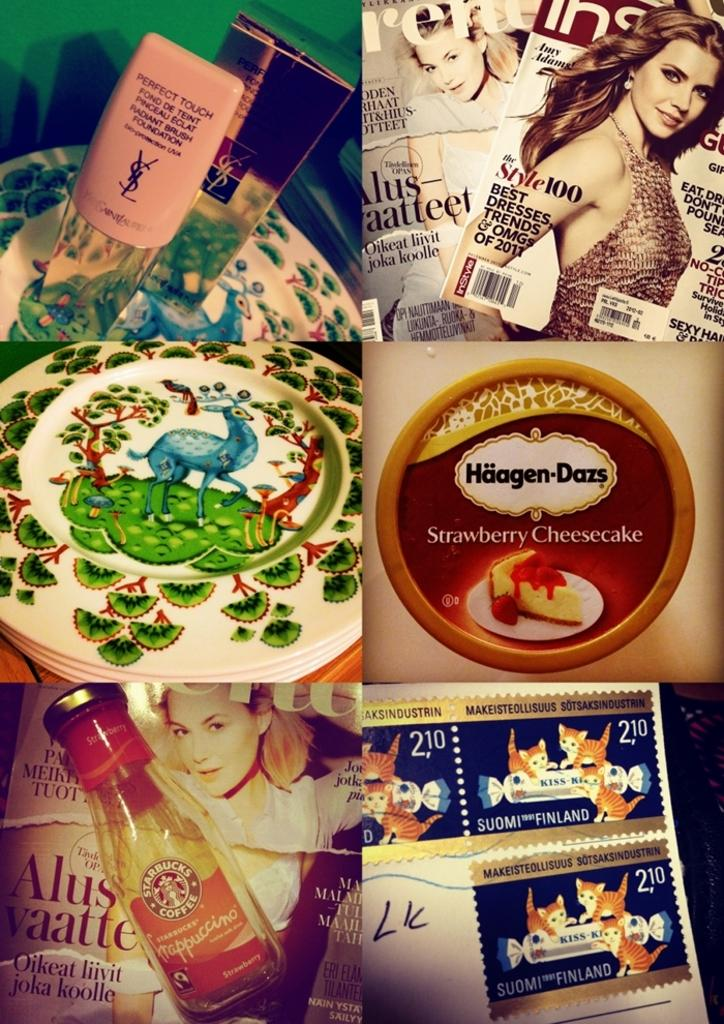<image>
Present a compact description of the photo's key features. Various items are shown together including stamps, a Starbucks coffee drink, and magazines. 